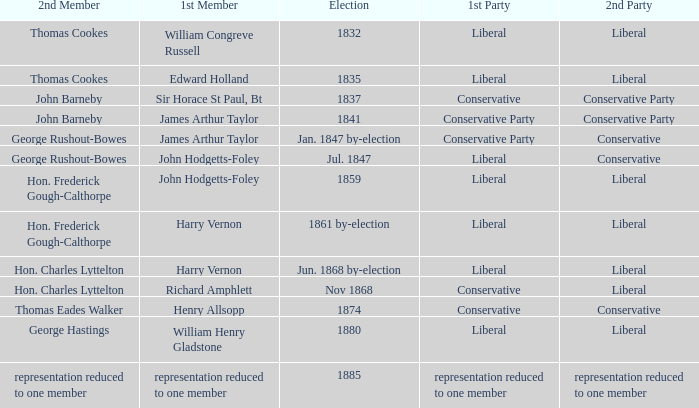What was the 1st Party when the 1st Member was William Congreve Russell? Liberal. 